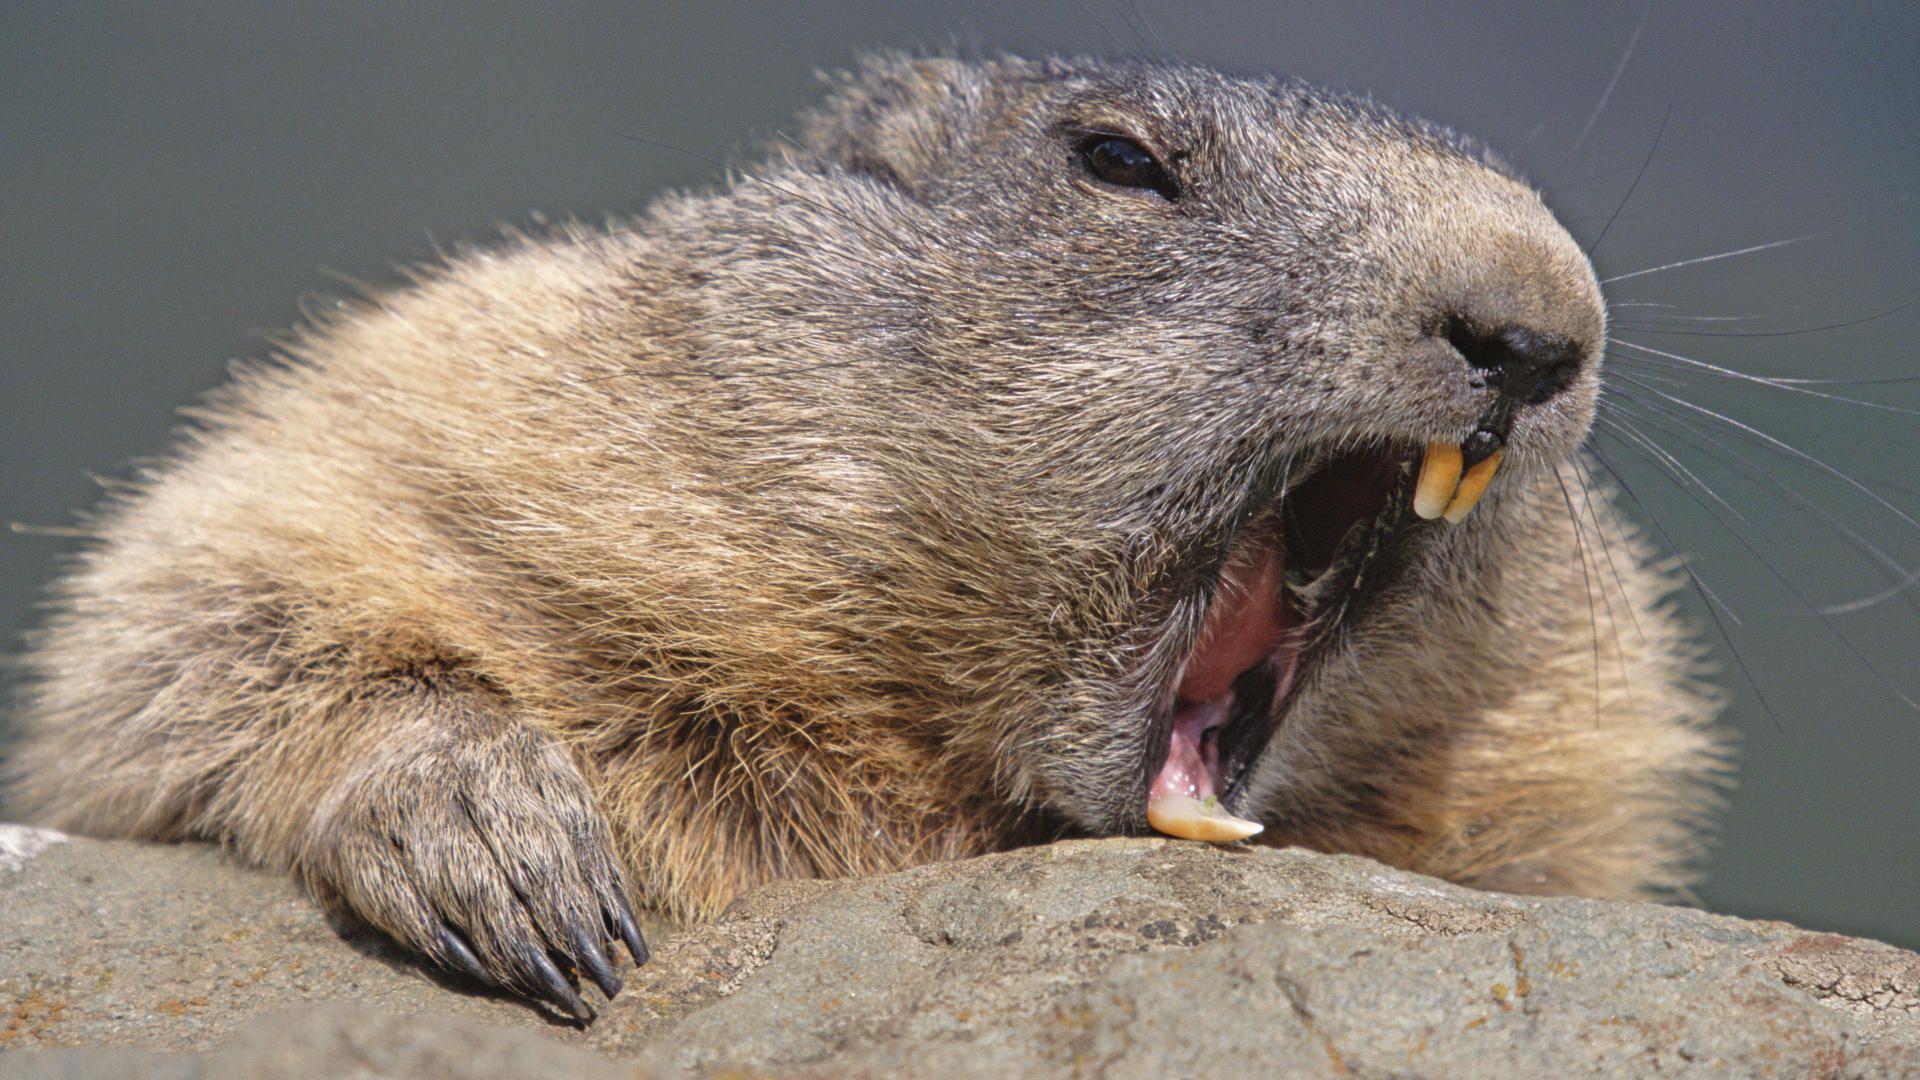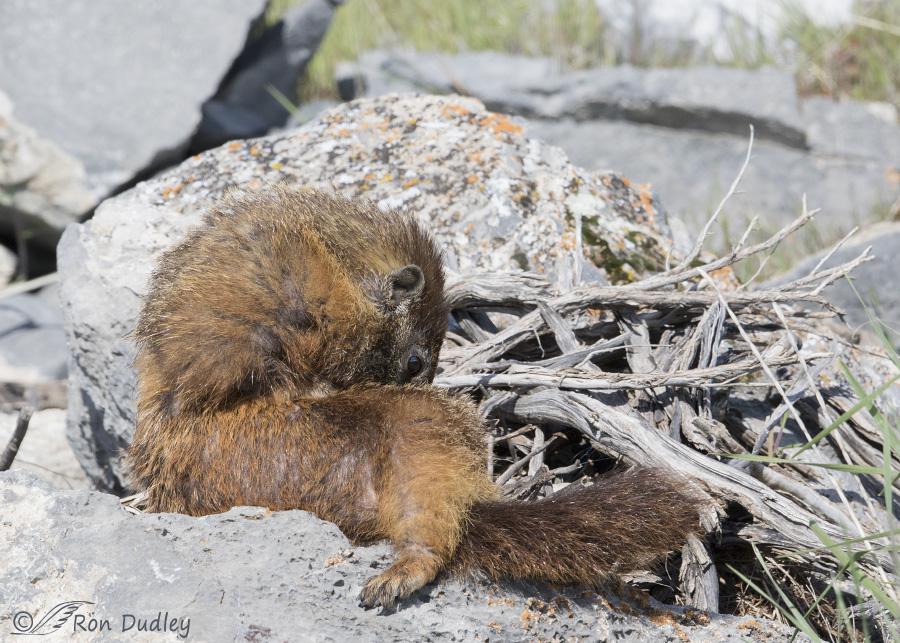The first image is the image on the left, the second image is the image on the right. Examine the images to the left and right. Is the description "One of the rodents is standing on its hind legs." accurate? Answer yes or no. No. 